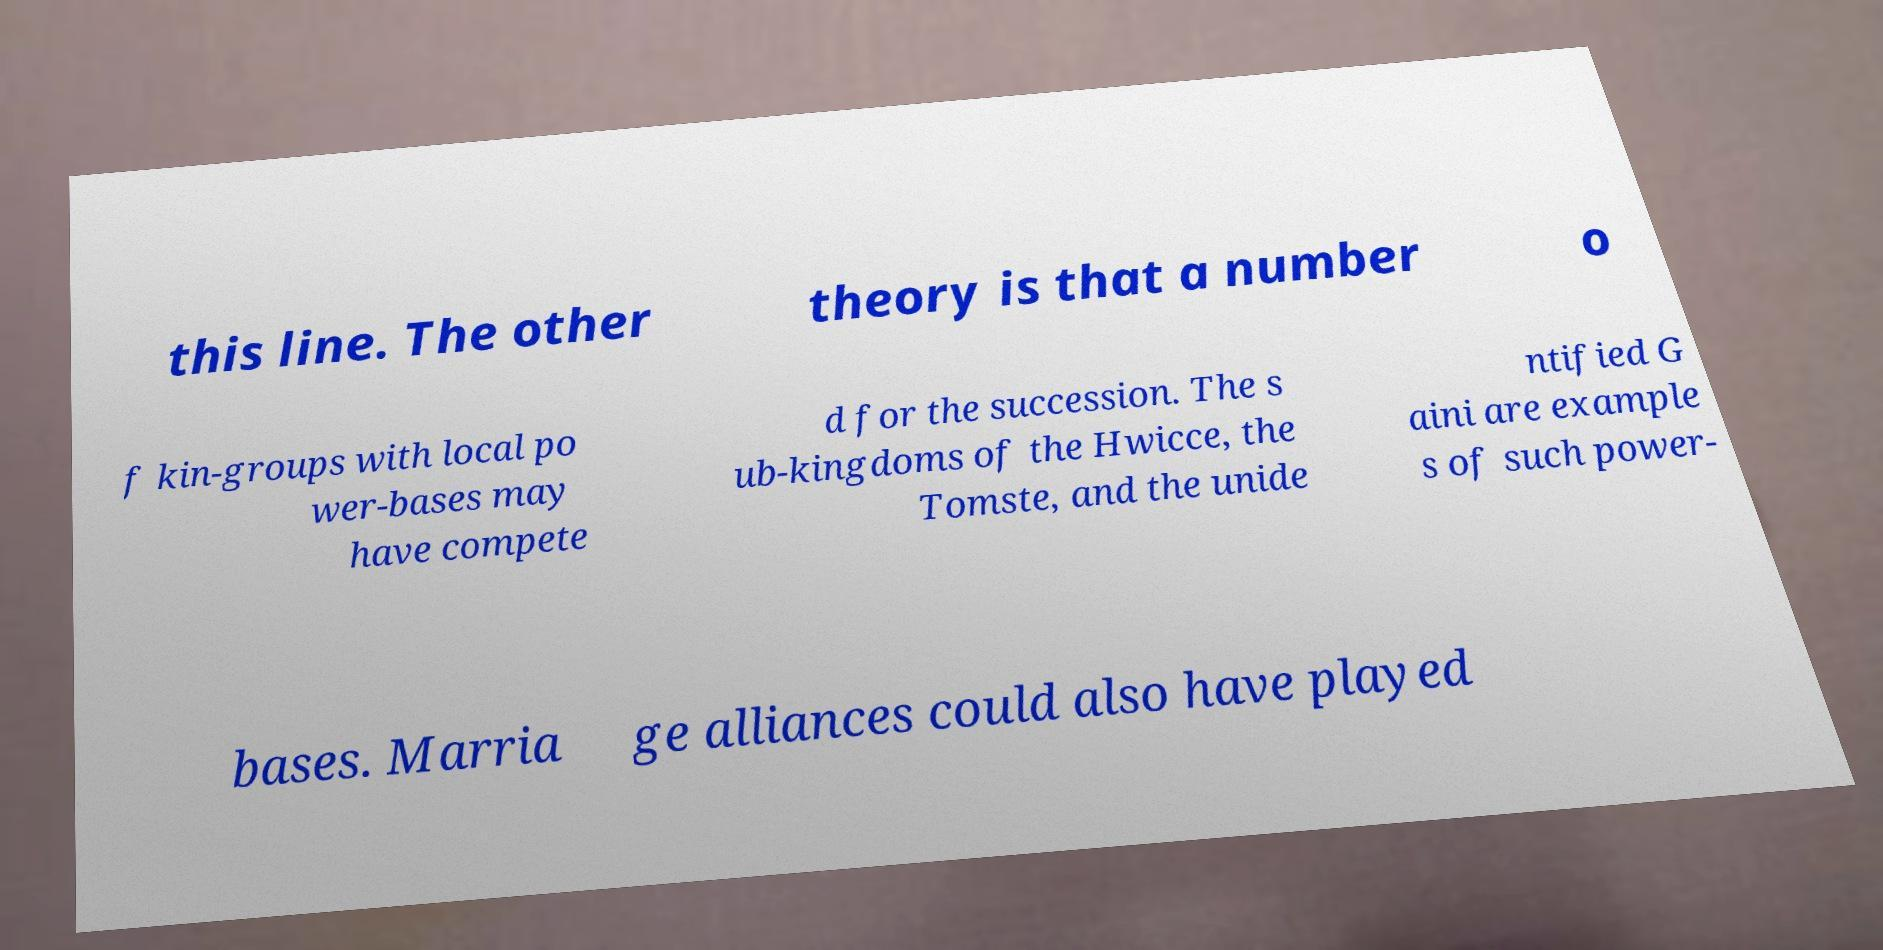There's text embedded in this image that I need extracted. Can you transcribe it verbatim? this line. The other theory is that a number o f kin-groups with local po wer-bases may have compete d for the succession. The s ub-kingdoms of the Hwicce, the Tomste, and the unide ntified G aini are example s of such power- bases. Marria ge alliances could also have played 